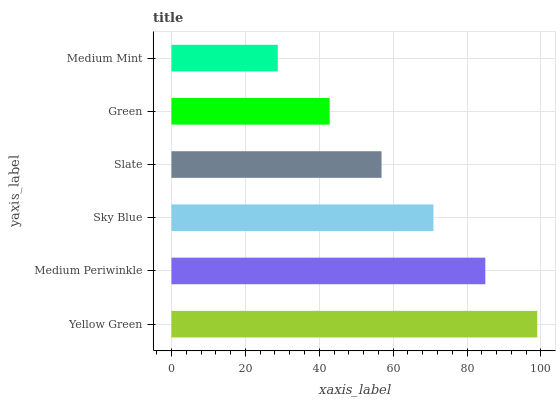Is Medium Mint the minimum?
Answer yes or no. Yes. Is Yellow Green the maximum?
Answer yes or no. Yes. Is Medium Periwinkle the minimum?
Answer yes or no. No. Is Medium Periwinkle the maximum?
Answer yes or no. No. Is Yellow Green greater than Medium Periwinkle?
Answer yes or no. Yes. Is Medium Periwinkle less than Yellow Green?
Answer yes or no. Yes. Is Medium Periwinkle greater than Yellow Green?
Answer yes or no. No. Is Yellow Green less than Medium Periwinkle?
Answer yes or no. No. Is Sky Blue the high median?
Answer yes or no. Yes. Is Slate the low median?
Answer yes or no. Yes. Is Slate the high median?
Answer yes or no. No. Is Yellow Green the low median?
Answer yes or no. No. 